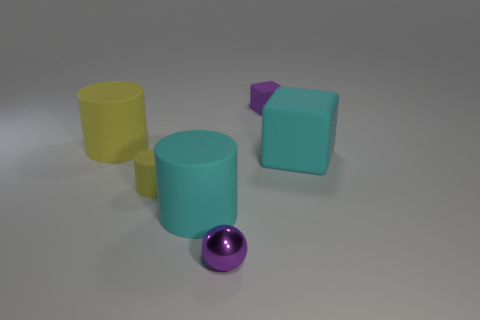Do the tiny cylinder and the cyan block have the same material?
Give a very brief answer. Yes. There is a tiny purple object that is in front of the big cyan rubber cylinder that is in front of the tiny yellow rubber thing; how many cyan rubber cubes are on the left side of it?
Provide a succinct answer. 0. Is there another small purple sphere made of the same material as the small ball?
Give a very brief answer. No. What size is the rubber cylinder that is the same color as the large block?
Keep it short and to the point. Large. Are there fewer large cyan rubber objects than tiny cubes?
Provide a succinct answer. No. There is a tiny matte thing that is right of the small metallic ball; is it the same color as the big rubber block?
Provide a short and direct response. No. What material is the tiny purple thing that is in front of the small matte thing in front of the purple thing that is on the right side of the small purple shiny object?
Give a very brief answer. Metal. Is there a small metal sphere of the same color as the small matte cylinder?
Give a very brief answer. No. Is the number of large matte cubes that are on the left side of the big cube less than the number of purple cubes?
Make the answer very short. Yes. Does the cyan matte object to the left of the purple metal thing have the same size as the purple shiny object?
Keep it short and to the point. No. 